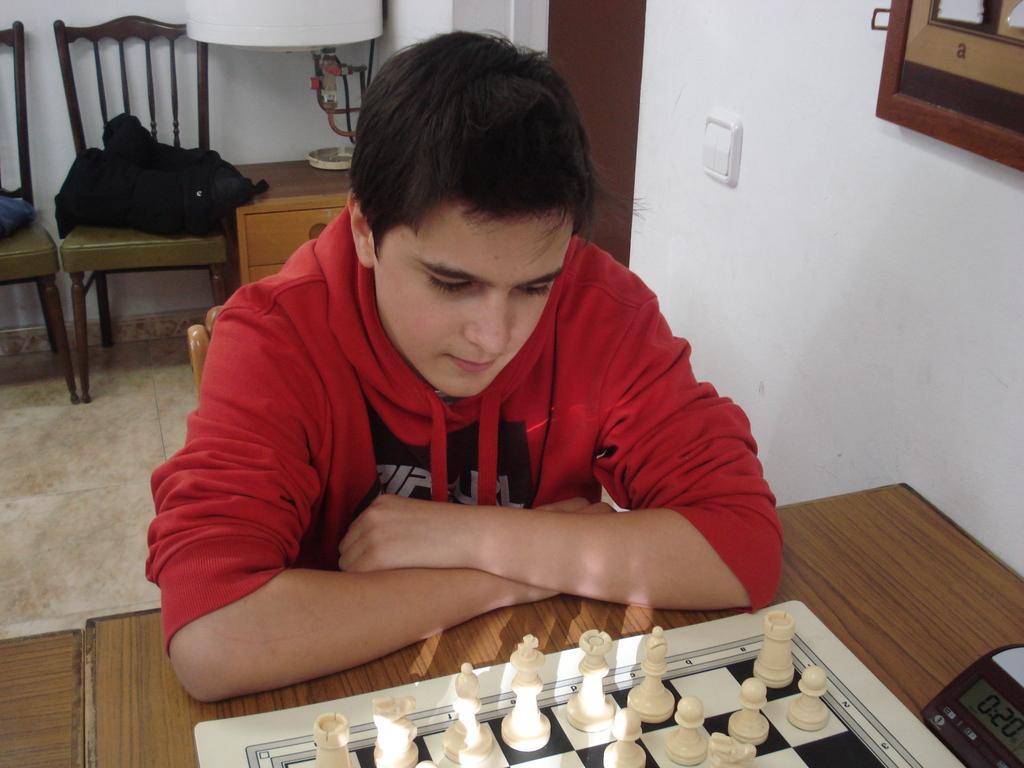Could you give a brief overview of what you see in this image? In this picture we can person a man in red shirt sitting on the chair in front of the table on which there is a chessboard and behind him there are two chair and a desk. 